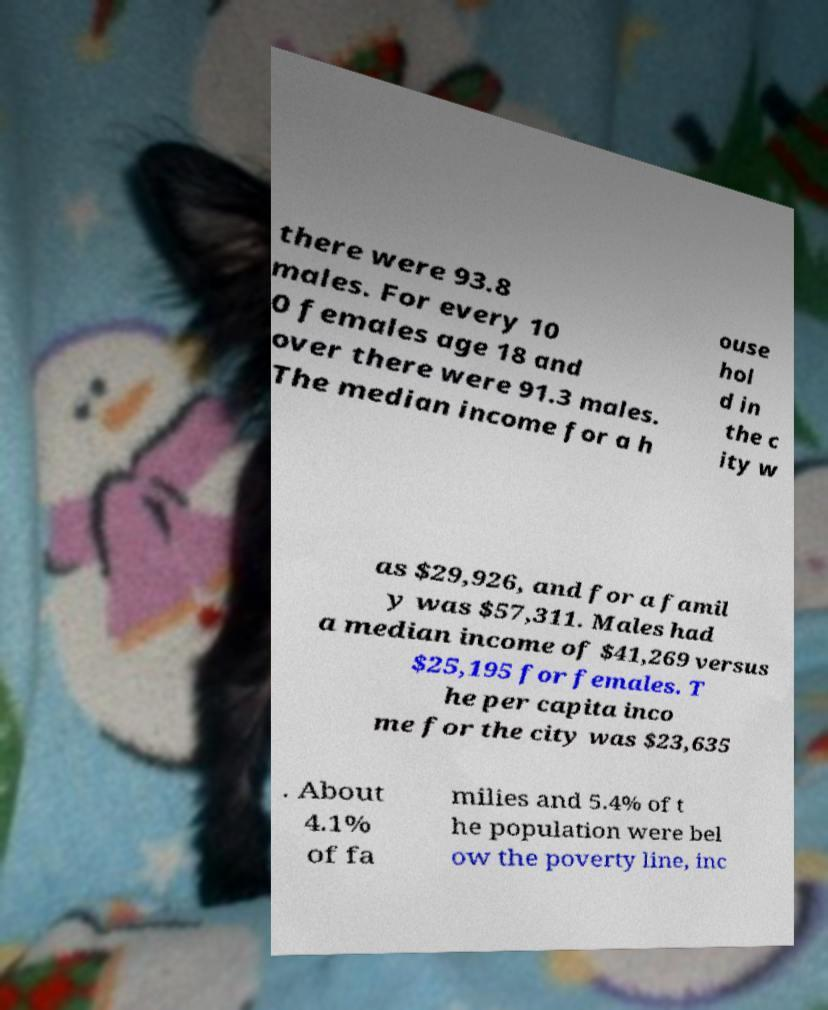What messages or text are displayed in this image? I need them in a readable, typed format. there were 93.8 males. For every 10 0 females age 18 and over there were 91.3 males. The median income for a h ouse hol d in the c ity w as $29,926, and for a famil y was $57,311. Males had a median income of $41,269 versus $25,195 for females. T he per capita inco me for the city was $23,635 . About 4.1% of fa milies and 5.4% of t he population were bel ow the poverty line, inc 